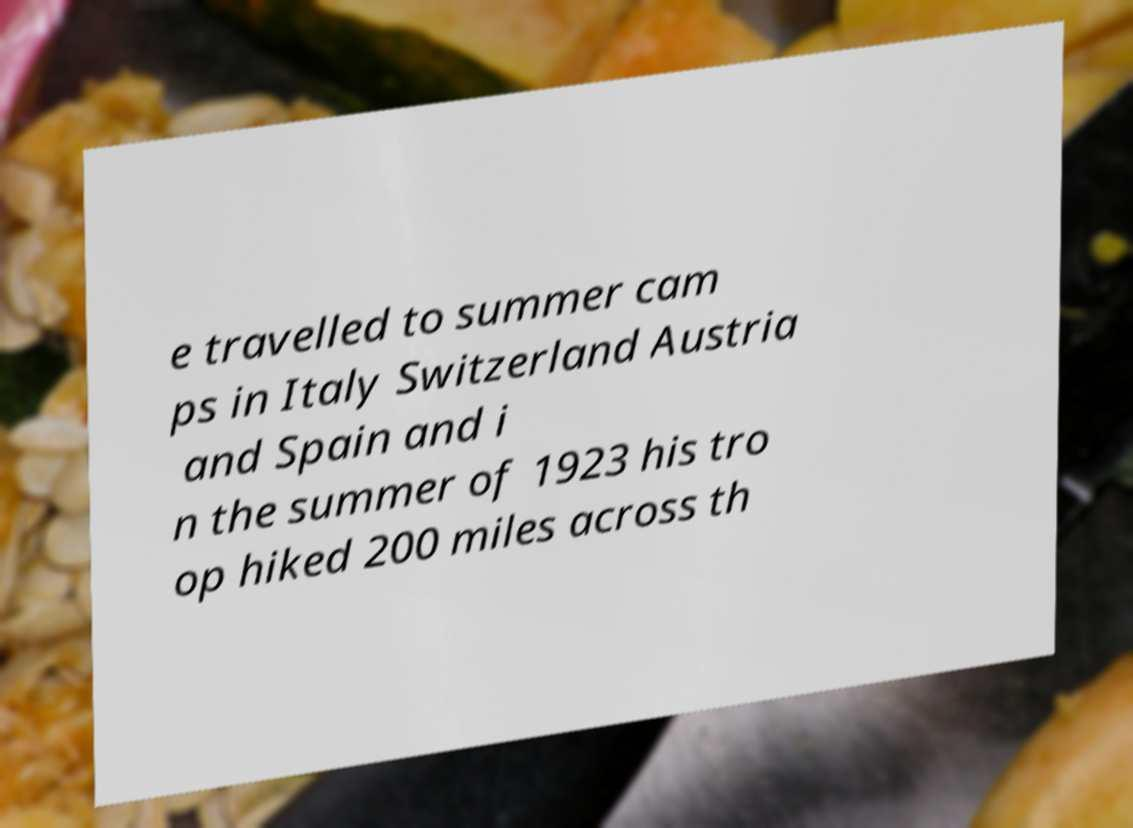There's text embedded in this image that I need extracted. Can you transcribe it verbatim? e travelled to summer cam ps in Italy Switzerland Austria and Spain and i n the summer of 1923 his tro op hiked 200 miles across th 